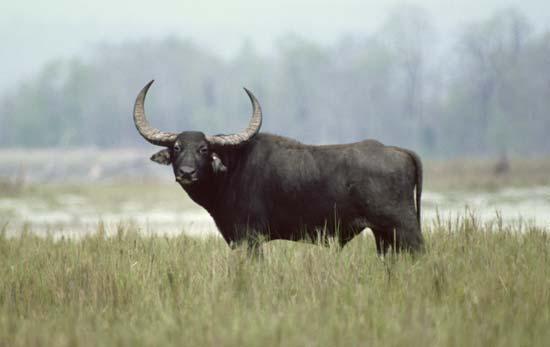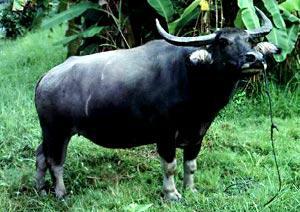The first image is the image on the left, the second image is the image on the right. Analyze the images presented: Is the assertion "The left image shows exactly one horned animal standing in a grassy area." valid? Answer yes or no. Yes. 